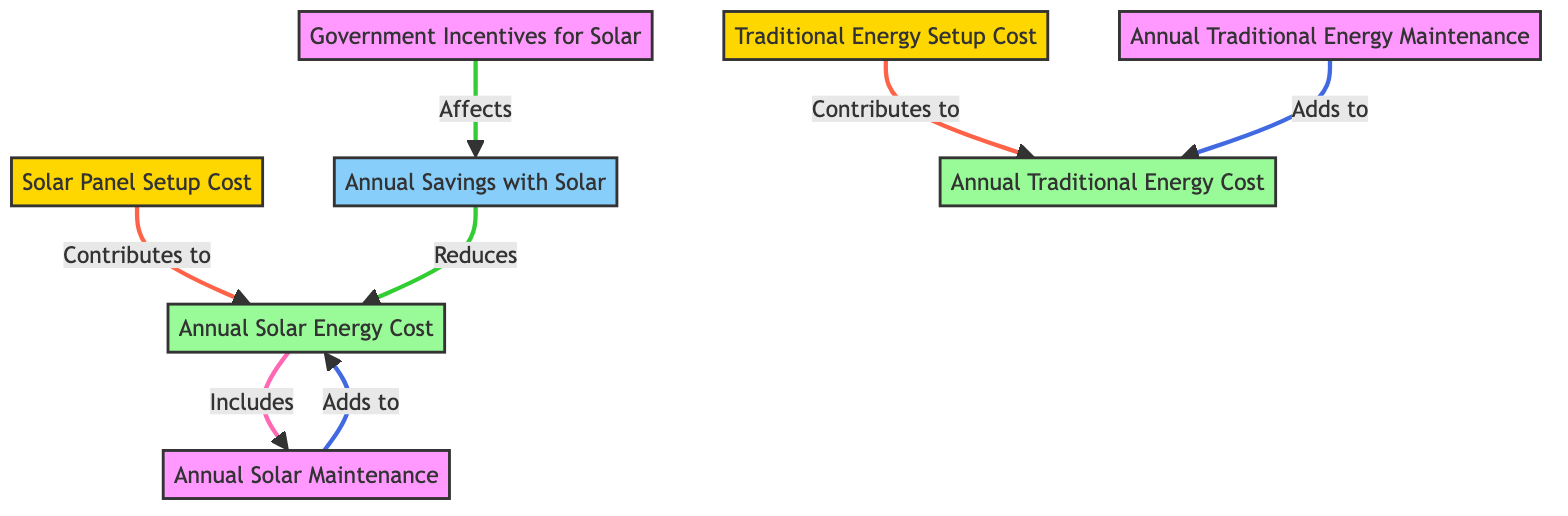What is the role of government incentives in solar savings? Government incentives directly affect solar savings as indicated by the arrow connecting them in the diagram. This suggests that government incentives can lead to an increase in annual savings when using solar energy.
Answer: Affects What does the traditional energy setup contribute to? The traditional energy setup contributes to the traditional energy cost, as shown in the direct connection between the traditional setup and traditional cost.
Answer: Traditional energy cost How many nodes represent costs in the diagram? The diagram includes three cost-related nodes: solar cost, traditional cost, and annual maintenance for both types. Counting these nodes gives a total of four.
Answer: Four What type of maintenance contributes to solar energy costs? The diagram specifies that "Annual Solar Maintenance" adds to the solar energy costs. This is a direct connection shown by the relationship in the flowchart.
Answer: Annual Solar Maintenance What reduces the annual solar energy cost? The annual savings with solar reduce the annual solar energy cost, as indicated by the arrow that shows savings impacting the cost negatively.
Answer: Annual Savings with Solar What is the relationship between solar setup and solar cost? The solar setup directly contributes to solar cost. This is depicted in the diagram where there is an arrow leading from solar setup to solar cost, indicating a one-way contribution.
Answer: Contributes to How do annual maintenance costs for traditional energy impact its overall cost? The annual traditional energy maintenance adds to the overall traditional energy cost, as shown by the directed relationship from annual maintenance to traditional cost in the diagram.
Answer: Adds to Which node shows the initial cost associated with solar? The node that shows the initial cost associated with solar is "Solar Panel Setup Cost," as it is the starting point leading into solar cost.
Answer: Solar Panel Setup Cost 